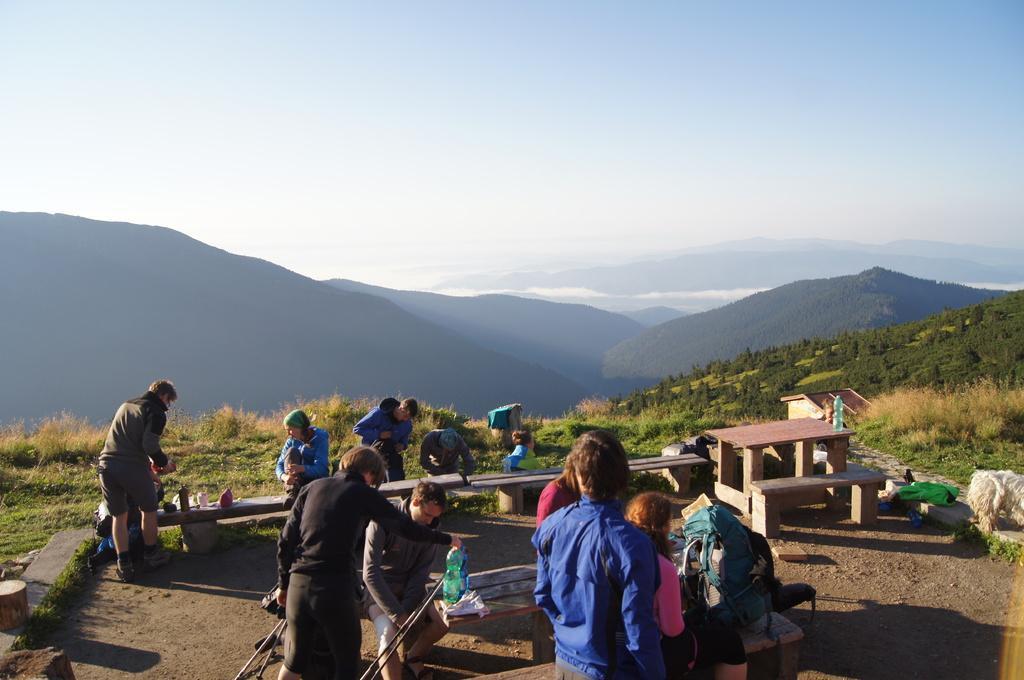Could you give a brief overview of what you see in this image? In this picture we can see groups of people, benches, bottles, sticks and some objects. Behind the people, there are hills, grass and the sky. 